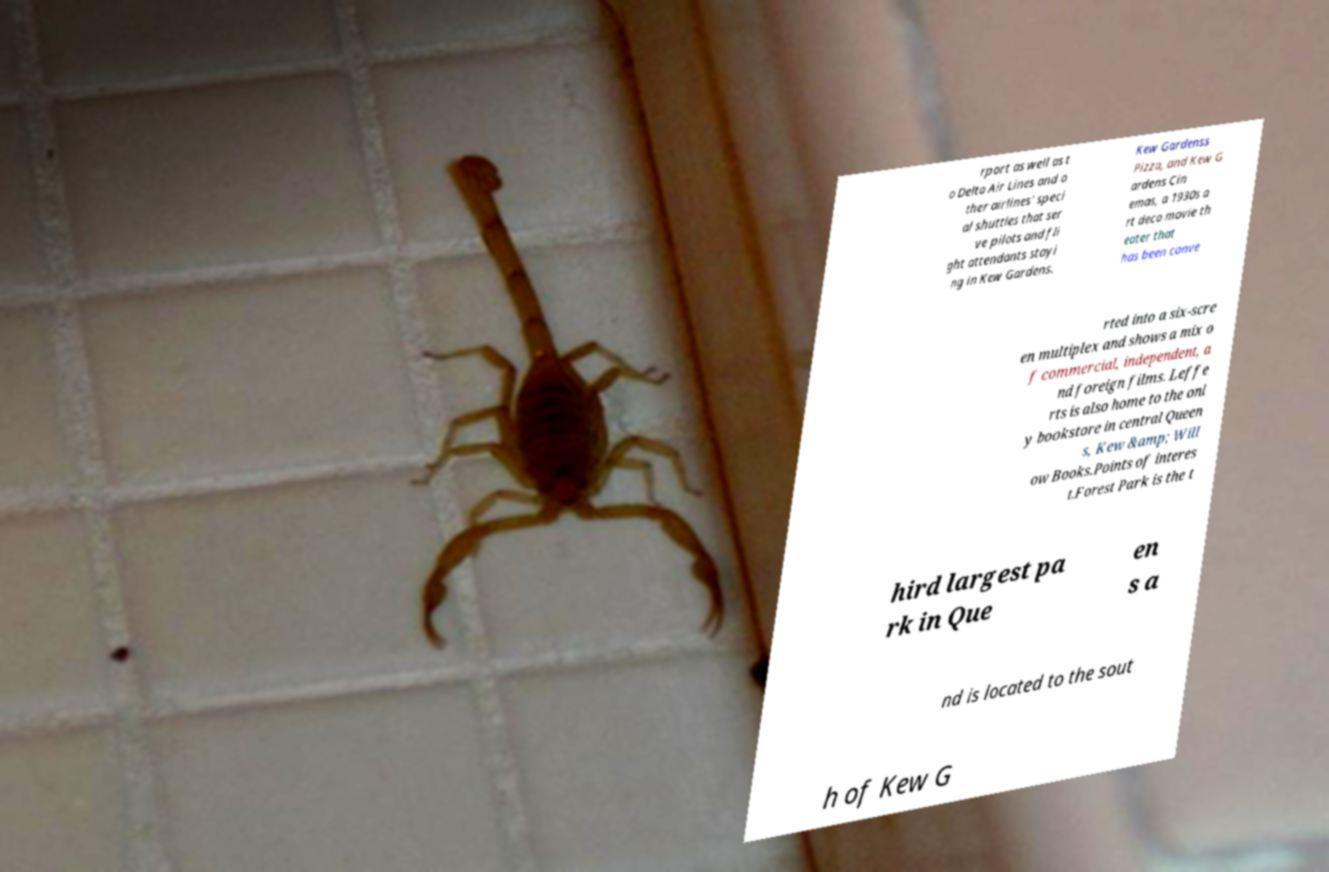Could you assist in decoding the text presented in this image and type it out clearly? rport as well as t o Delta Air Lines and o ther airlines' speci al shuttles that ser ve pilots and fli ght attendants stayi ng in Kew Gardens. Kew Gardenss Pizza, and Kew G ardens Cin emas, a 1930s a rt deco movie th eater that has been conve rted into a six-scre en multiplex and shows a mix o f commercial, independent, a nd foreign films. Leffe rts is also home to the onl y bookstore in central Queen s, Kew &amp; Will ow Books.Points of interes t.Forest Park is the t hird largest pa rk in Que en s a nd is located to the sout h of Kew G 